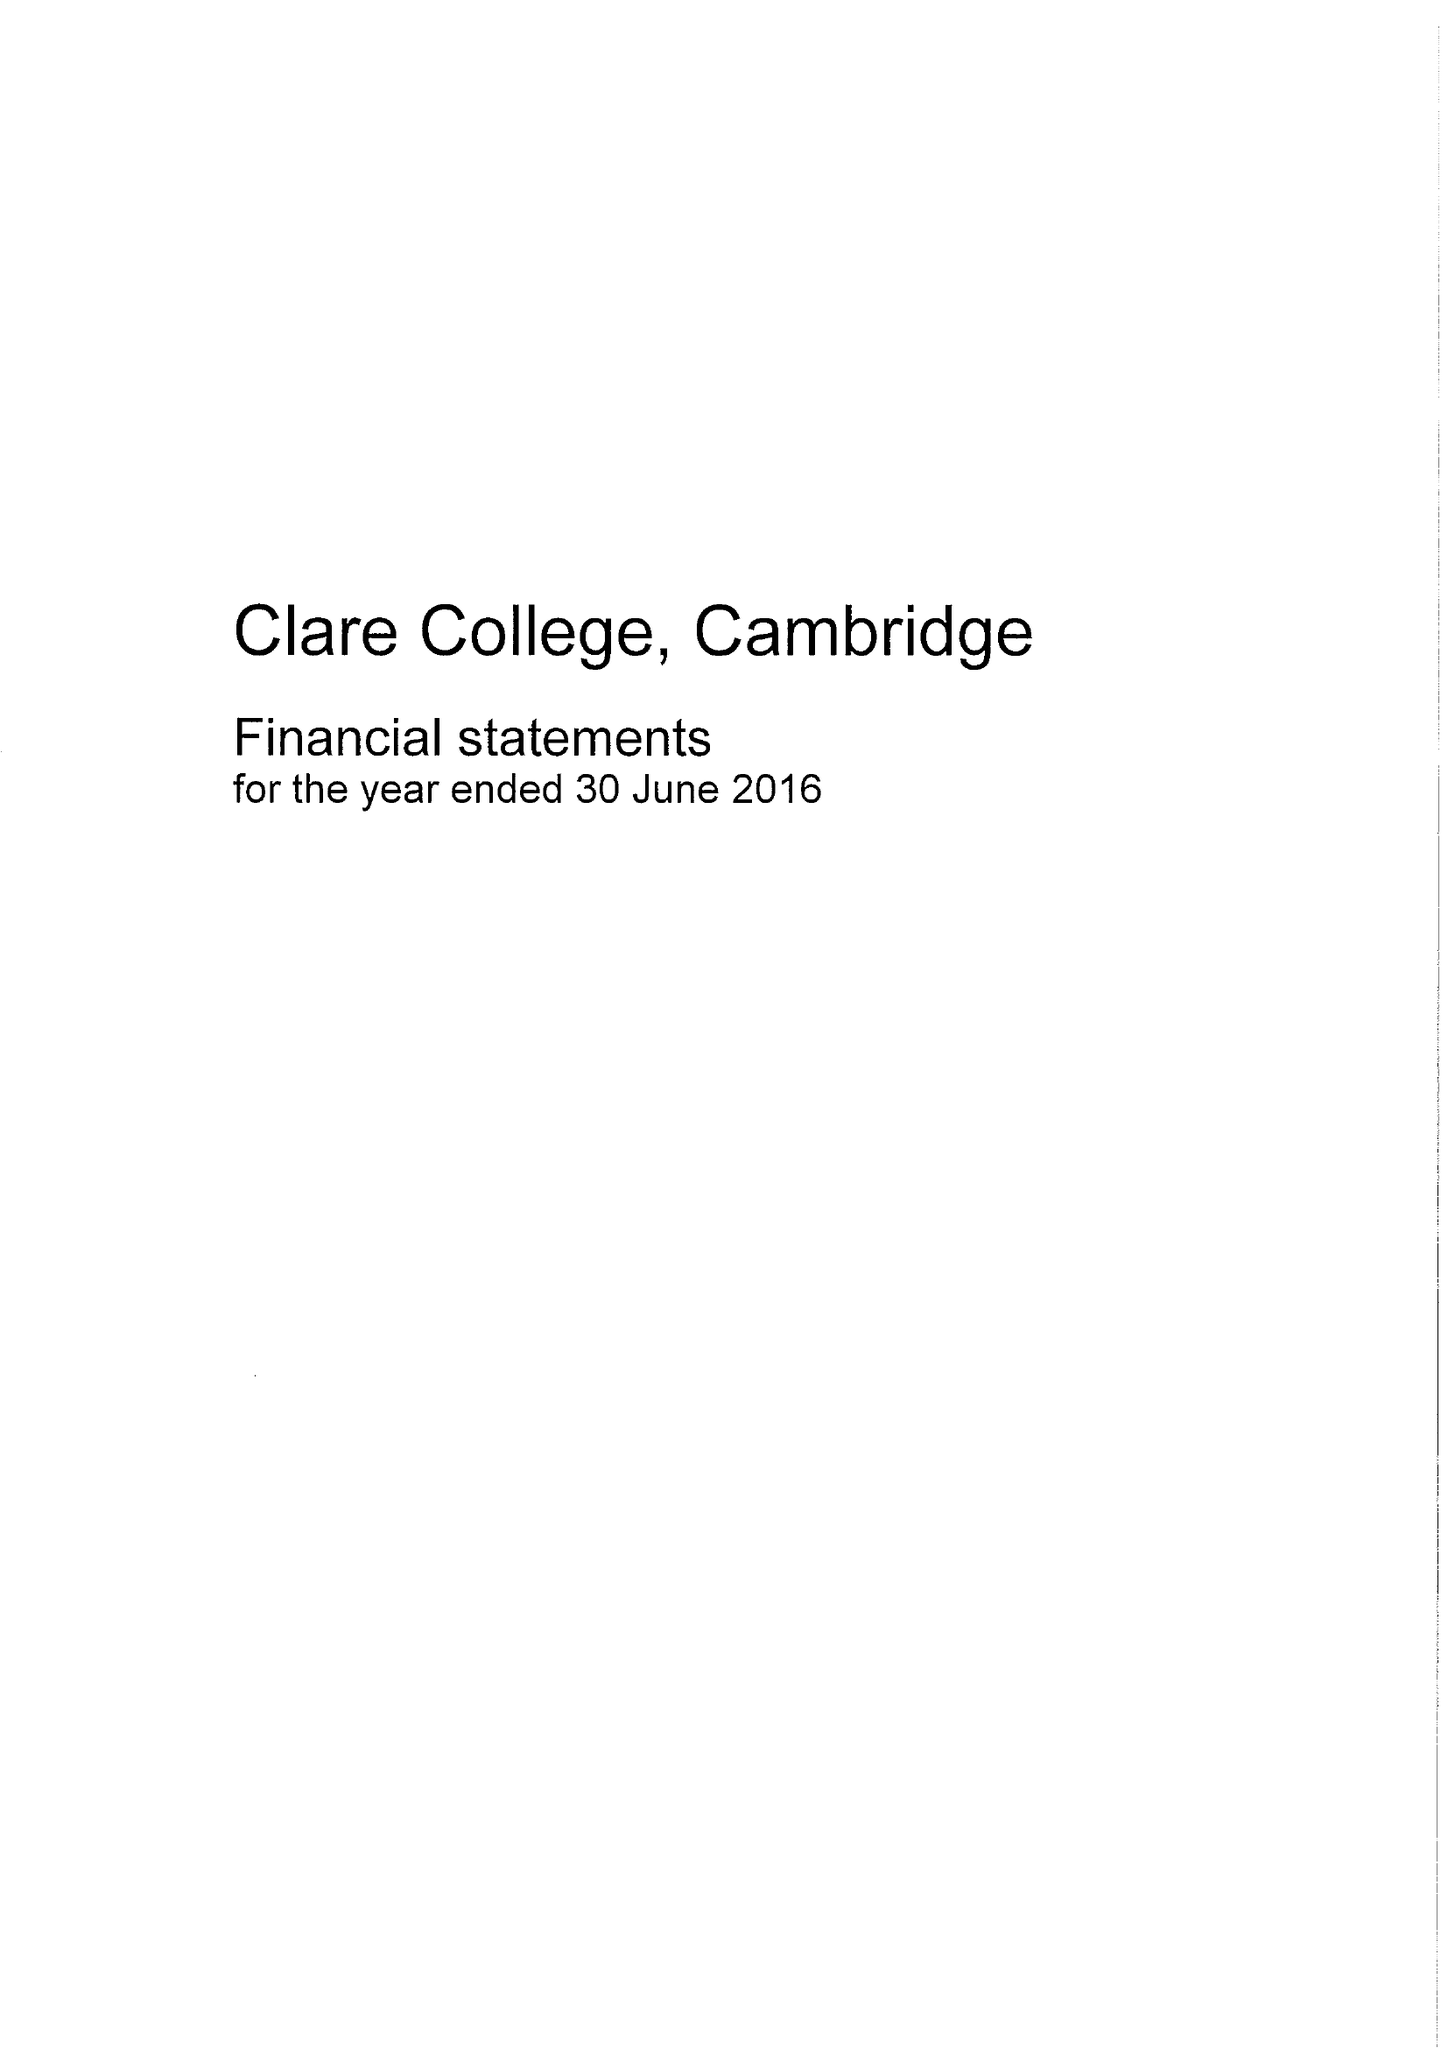What is the value for the report_date?
Answer the question using a single word or phrase. 2016-06-30 